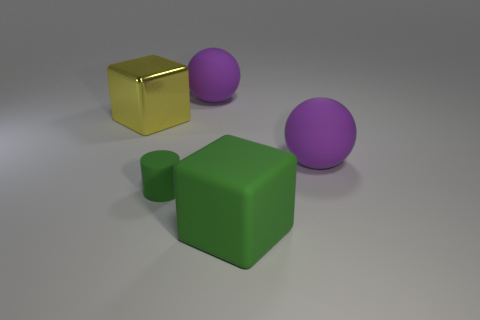Add 3 big rubber objects. How many objects exist? 8 Subtract all cylinders. How many objects are left? 4 Add 1 tiny green matte objects. How many tiny green matte objects are left? 2 Add 5 green cubes. How many green cubes exist? 6 Subtract 0 brown blocks. How many objects are left? 5 Subtract all tiny matte cylinders. Subtract all yellow cubes. How many objects are left? 3 